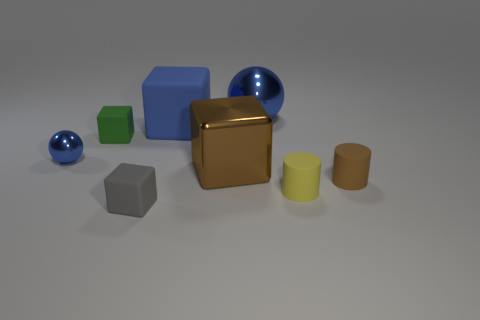There is a big ball that is the same color as the tiny ball; what material is it?
Your response must be concise. Metal. How many other objects are there of the same material as the small yellow object?
Your answer should be very brief. 4. What number of gray spheres are there?
Your answer should be very brief. 0. What number of things are brown cylinders or large blocks to the left of the big brown object?
Give a very brief answer. 2. There is a blue shiny object that is left of the blue rubber object; does it have the same size as the tiny green rubber object?
Give a very brief answer. Yes. How many rubber objects are either small red balls or small brown objects?
Your answer should be very brief. 1. There is a blue shiny ball to the right of the tiny gray rubber block; what is its size?
Give a very brief answer. Large. Does the tiny gray rubber object have the same shape as the tiny green thing?
Offer a terse response. Yes. What number of large objects are green matte blocks or gray matte things?
Your answer should be very brief. 0. Are there any small metal spheres to the left of the small blue object?
Your answer should be very brief. No. 